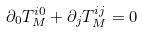<formula> <loc_0><loc_0><loc_500><loc_500>\partial _ { 0 } T _ { M } ^ { i 0 } + \partial _ { j } T _ { M } ^ { i j } = 0</formula> 